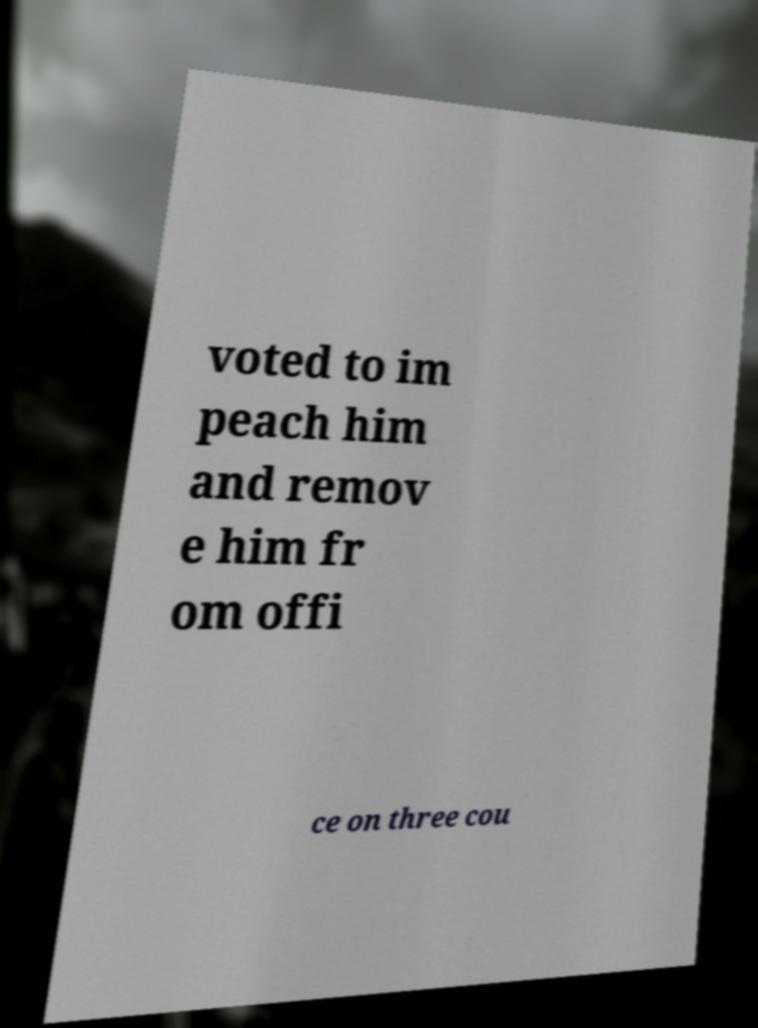What messages or text are displayed in this image? I need them in a readable, typed format. voted to im peach him and remov e him fr om offi ce on three cou 